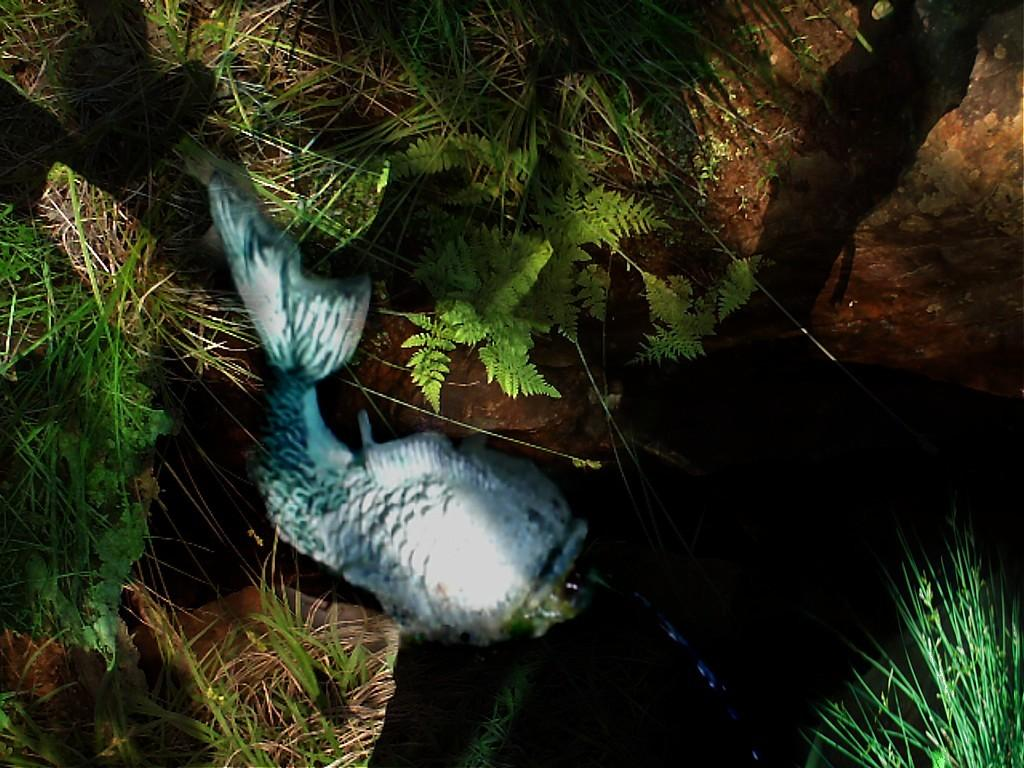What is the main subject of the image? There is a statue of a fish in the image. What other objects or elements can be seen in the image? There are stones and plants in the image. What type of support can be seen in the image? There is no support visible in the image; it features a statue of a fish, stones, and plants. What attempt is being made by the fish in the image? The fish is a statue and therefore not making any attempts or actions. 